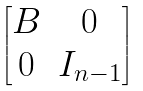Convert formula to latex. <formula><loc_0><loc_0><loc_500><loc_500>\begin{bmatrix} B & 0 \\ 0 & I _ { n - 1 } \end{bmatrix}</formula> 